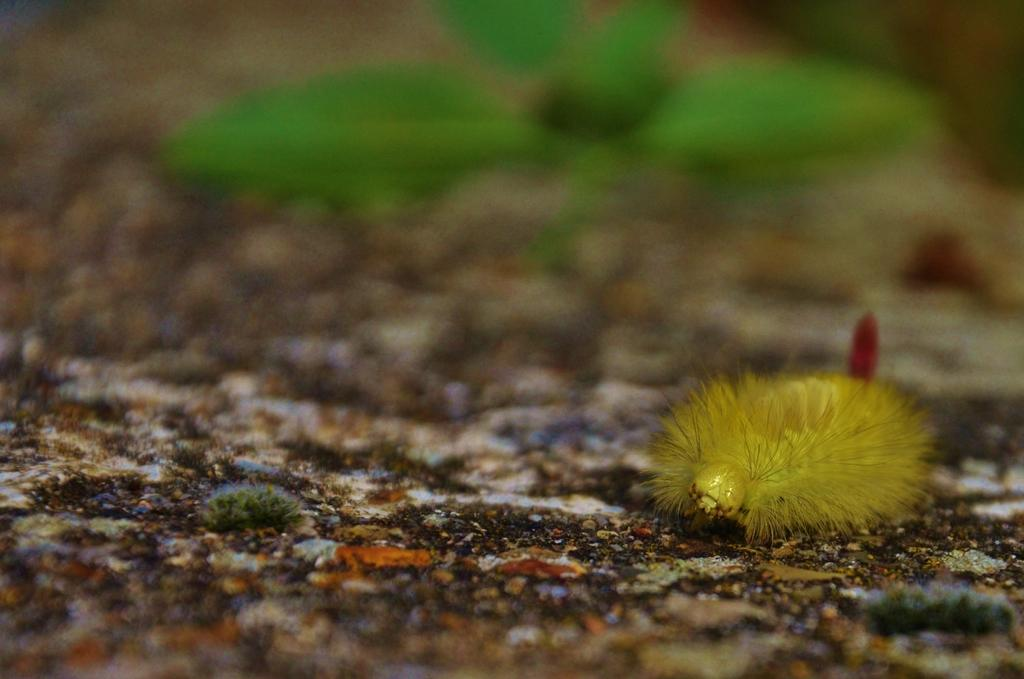What type of insect is in the image? There is a yellow color insect in the image. Where is the insect located? The insect is on the ground. Can you describe the background of the image? The background of the image is blurred. What type of beef can be seen in the image? There is no beef present in the image; it features a yellow color insect on the ground with a blurred background. 